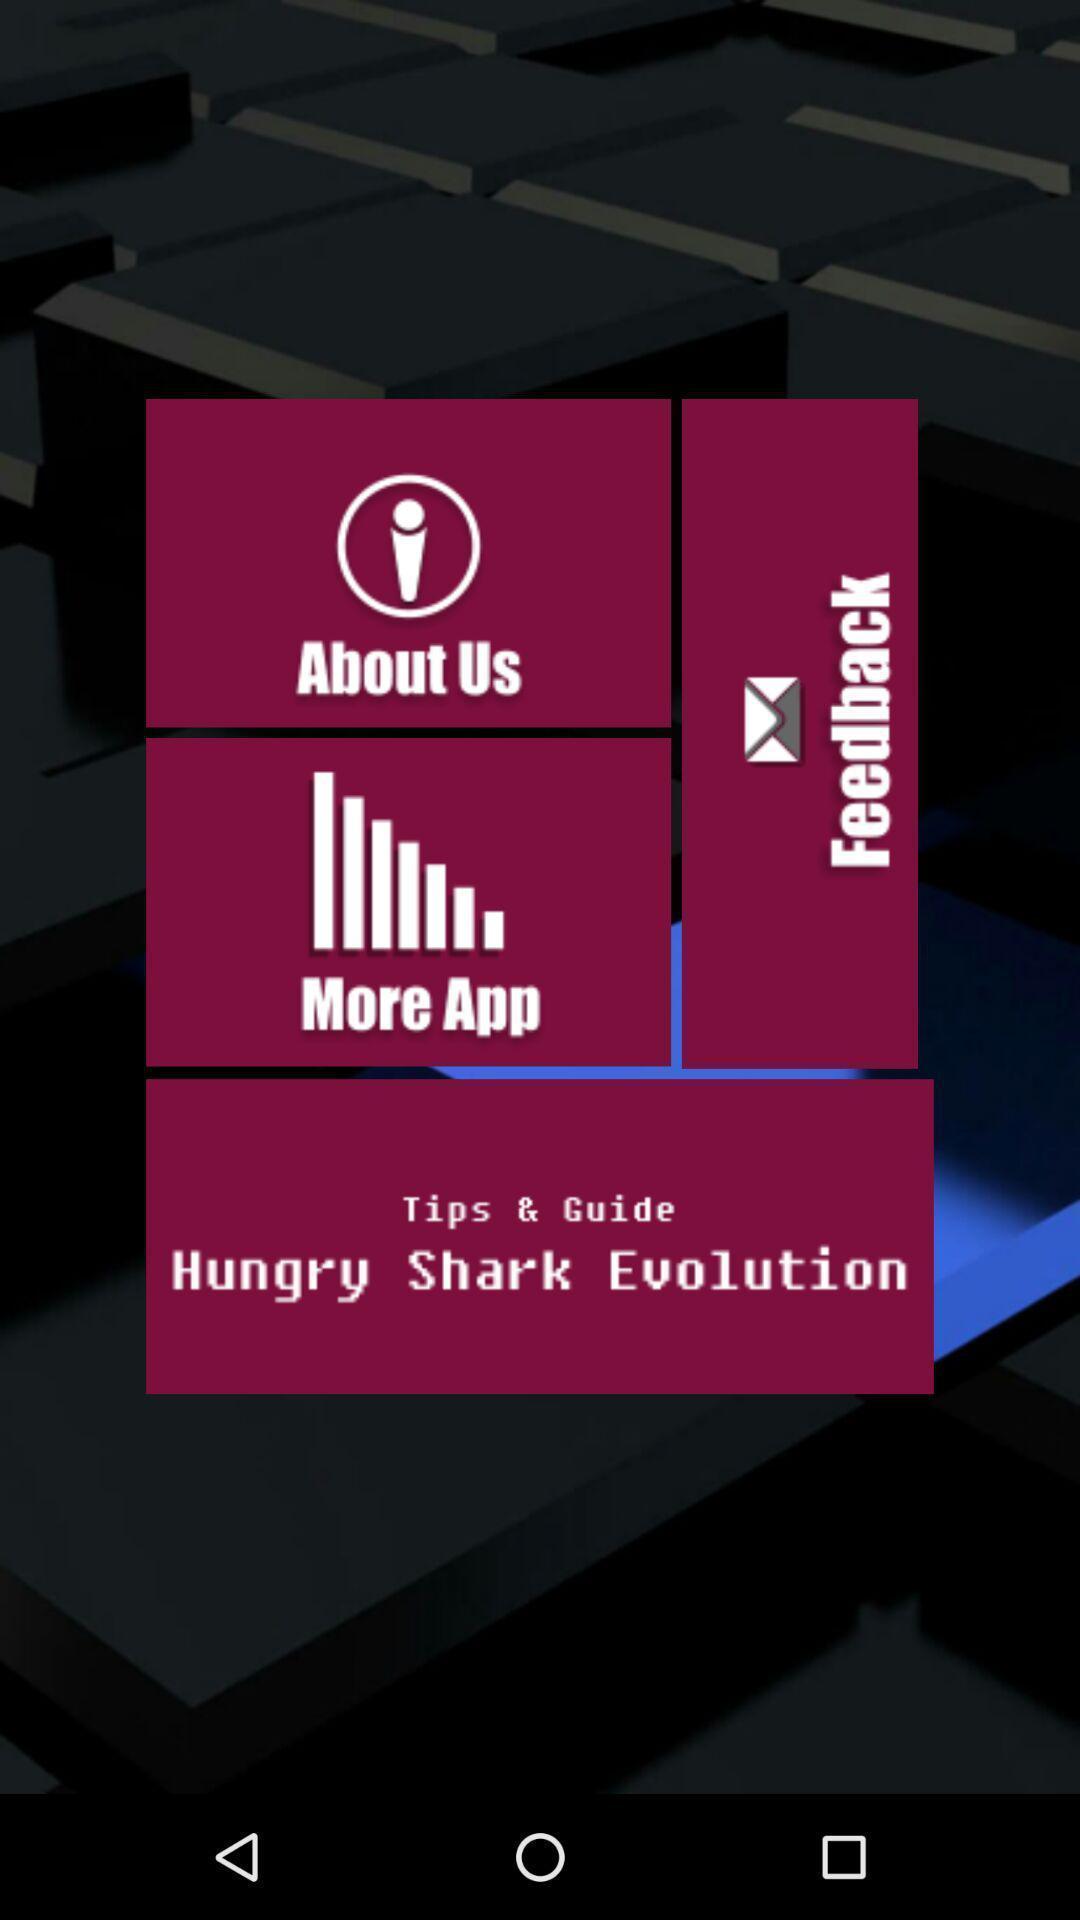Describe the visual elements of this screenshot. Screen displaying the list of categories. 